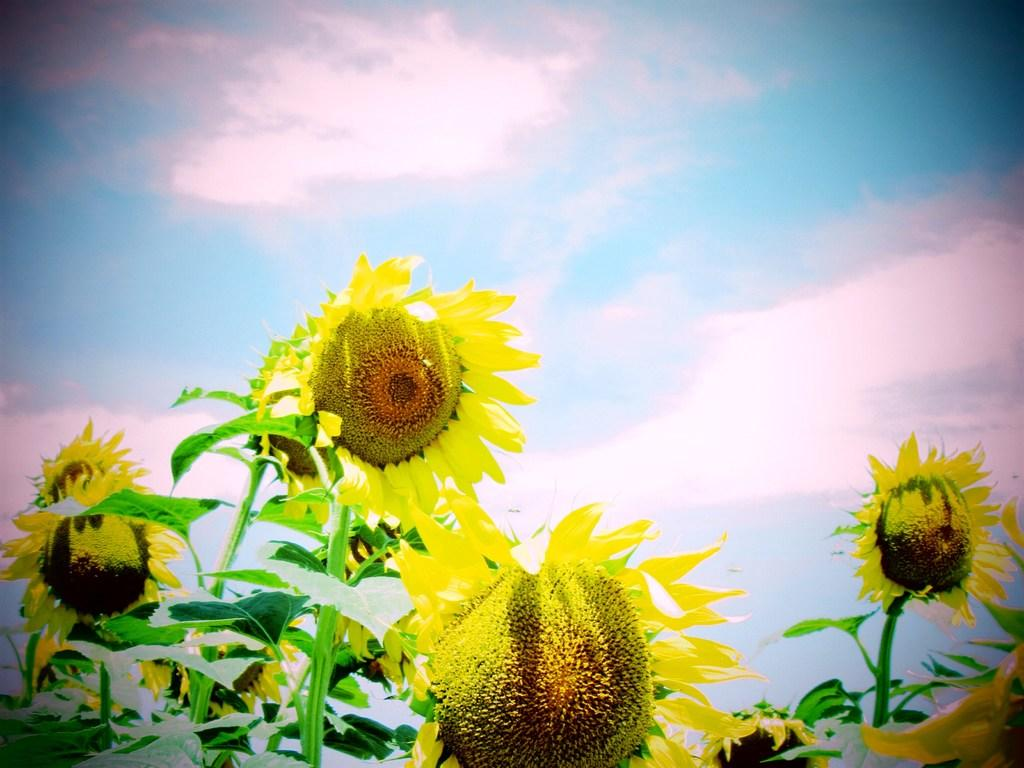What type of plants are in the image? The plants in the image have yellow sunflowers and green leaves. What color are the sunflowers on the plants? The sunflowers on the plants are yellow. What color are the leaves on the plants? The leaves on the plants are green. What can be seen in the background of the image? There are clouds in the background of the image. What color is the sky in the image? The sky in the image is blue. Where is the attention-grabbing crook sitting in the lunchroom in the image? There is no mention of a crook or a lunchroom in the image; it features plants with yellow sunflowers and green leaves, clouds in the background, and a blue sky. 